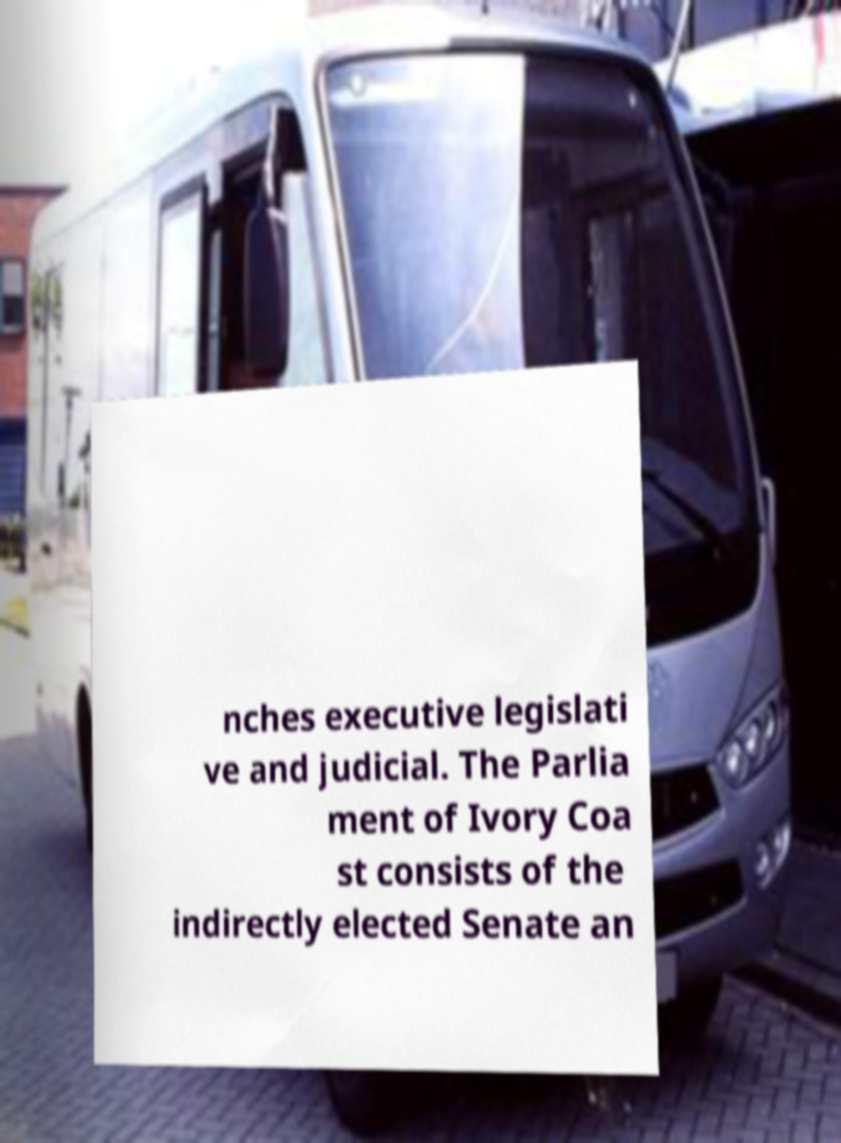Please read and relay the text visible in this image. What does it say? nches executive legislati ve and judicial. The Parlia ment of Ivory Coa st consists of the indirectly elected Senate an 